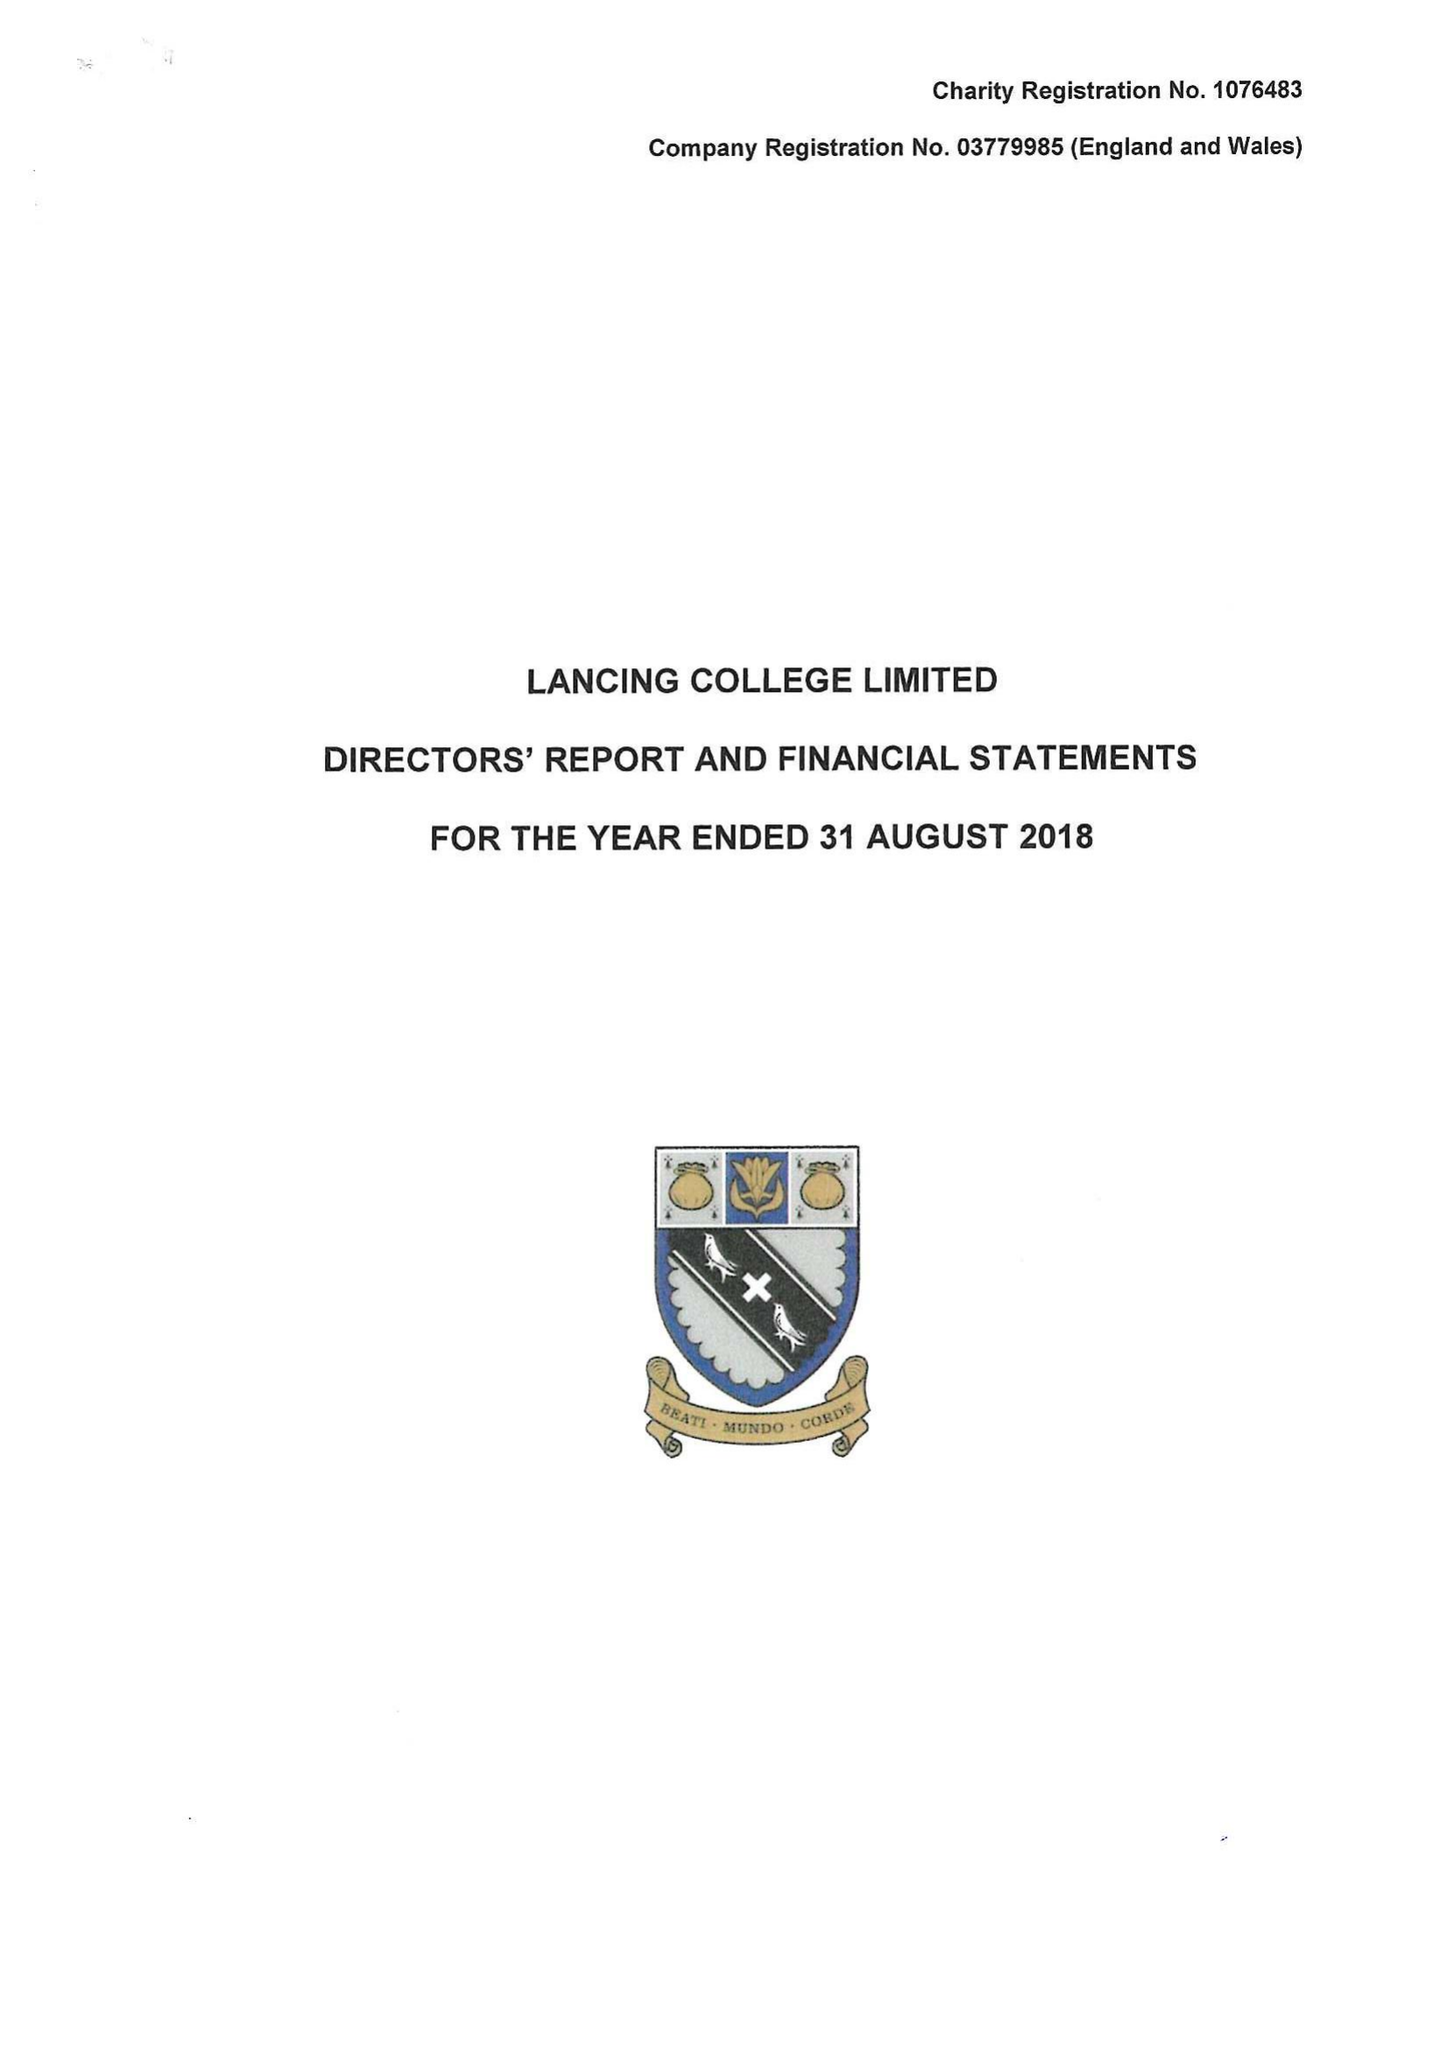What is the value for the spending_annually_in_british_pounds?
Answer the question using a single word or phrase. 20695692.00 